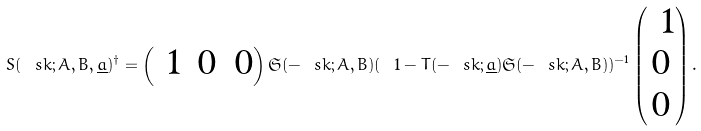<formula> <loc_0><loc_0><loc_500><loc_500>S ( \ s k ; A , B , \underline { a } ) ^ { \dagger } = \begin{pmatrix} \ 1 & 0 & 0 \end{pmatrix} \mathfrak { S } ( - \ s k ; A , B ) ( \ 1 - T ( - \ s k ; \underline { a } ) \mathfrak { S } ( - \ s k ; A , B ) ) ^ { - 1 } \begin{pmatrix} \ 1 \\ 0 \\ 0 \end{pmatrix} .</formula> 